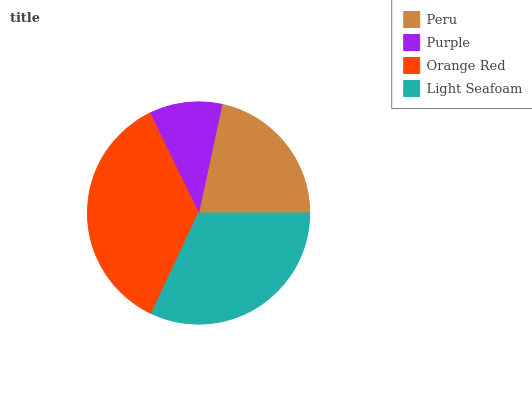Is Purple the minimum?
Answer yes or no. Yes. Is Orange Red the maximum?
Answer yes or no. Yes. Is Orange Red the minimum?
Answer yes or no. No. Is Purple the maximum?
Answer yes or no. No. Is Orange Red greater than Purple?
Answer yes or no. Yes. Is Purple less than Orange Red?
Answer yes or no. Yes. Is Purple greater than Orange Red?
Answer yes or no. No. Is Orange Red less than Purple?
Answer yes or no. No. Is Light Seafoam the high median?
Answer yes or no. Yes. Is Peru the low median?
Answer yes or no. Yes. Is Purple the high median?
Answer yes or no. No. Is Light Seafoam the low median?
Answer yes or no. No. 